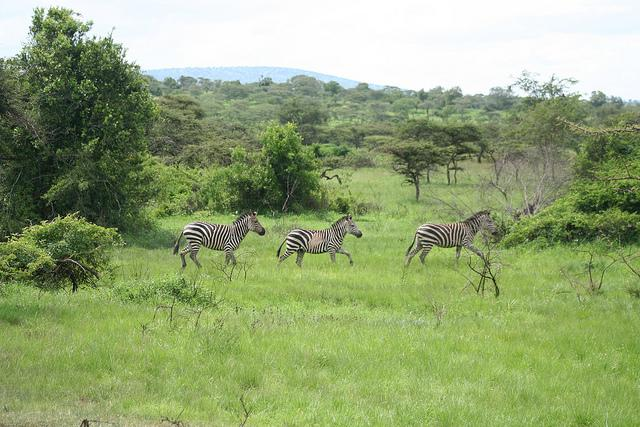What place are the zebra in?

Choices:
A) farm
B) zoo
C) park
D) wilderness wilderness 